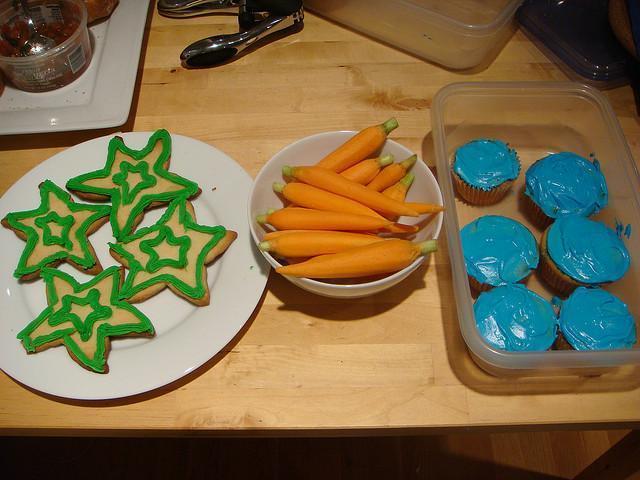How many cakes are there?
Give a very brief answer. 2. How many carrots are there?
Give a very brief answer. 4. How many bowls can be seen?
Give a very brief answer. 3. How many people do you see with their arms lifted?
Give a very brief answer. 0. 